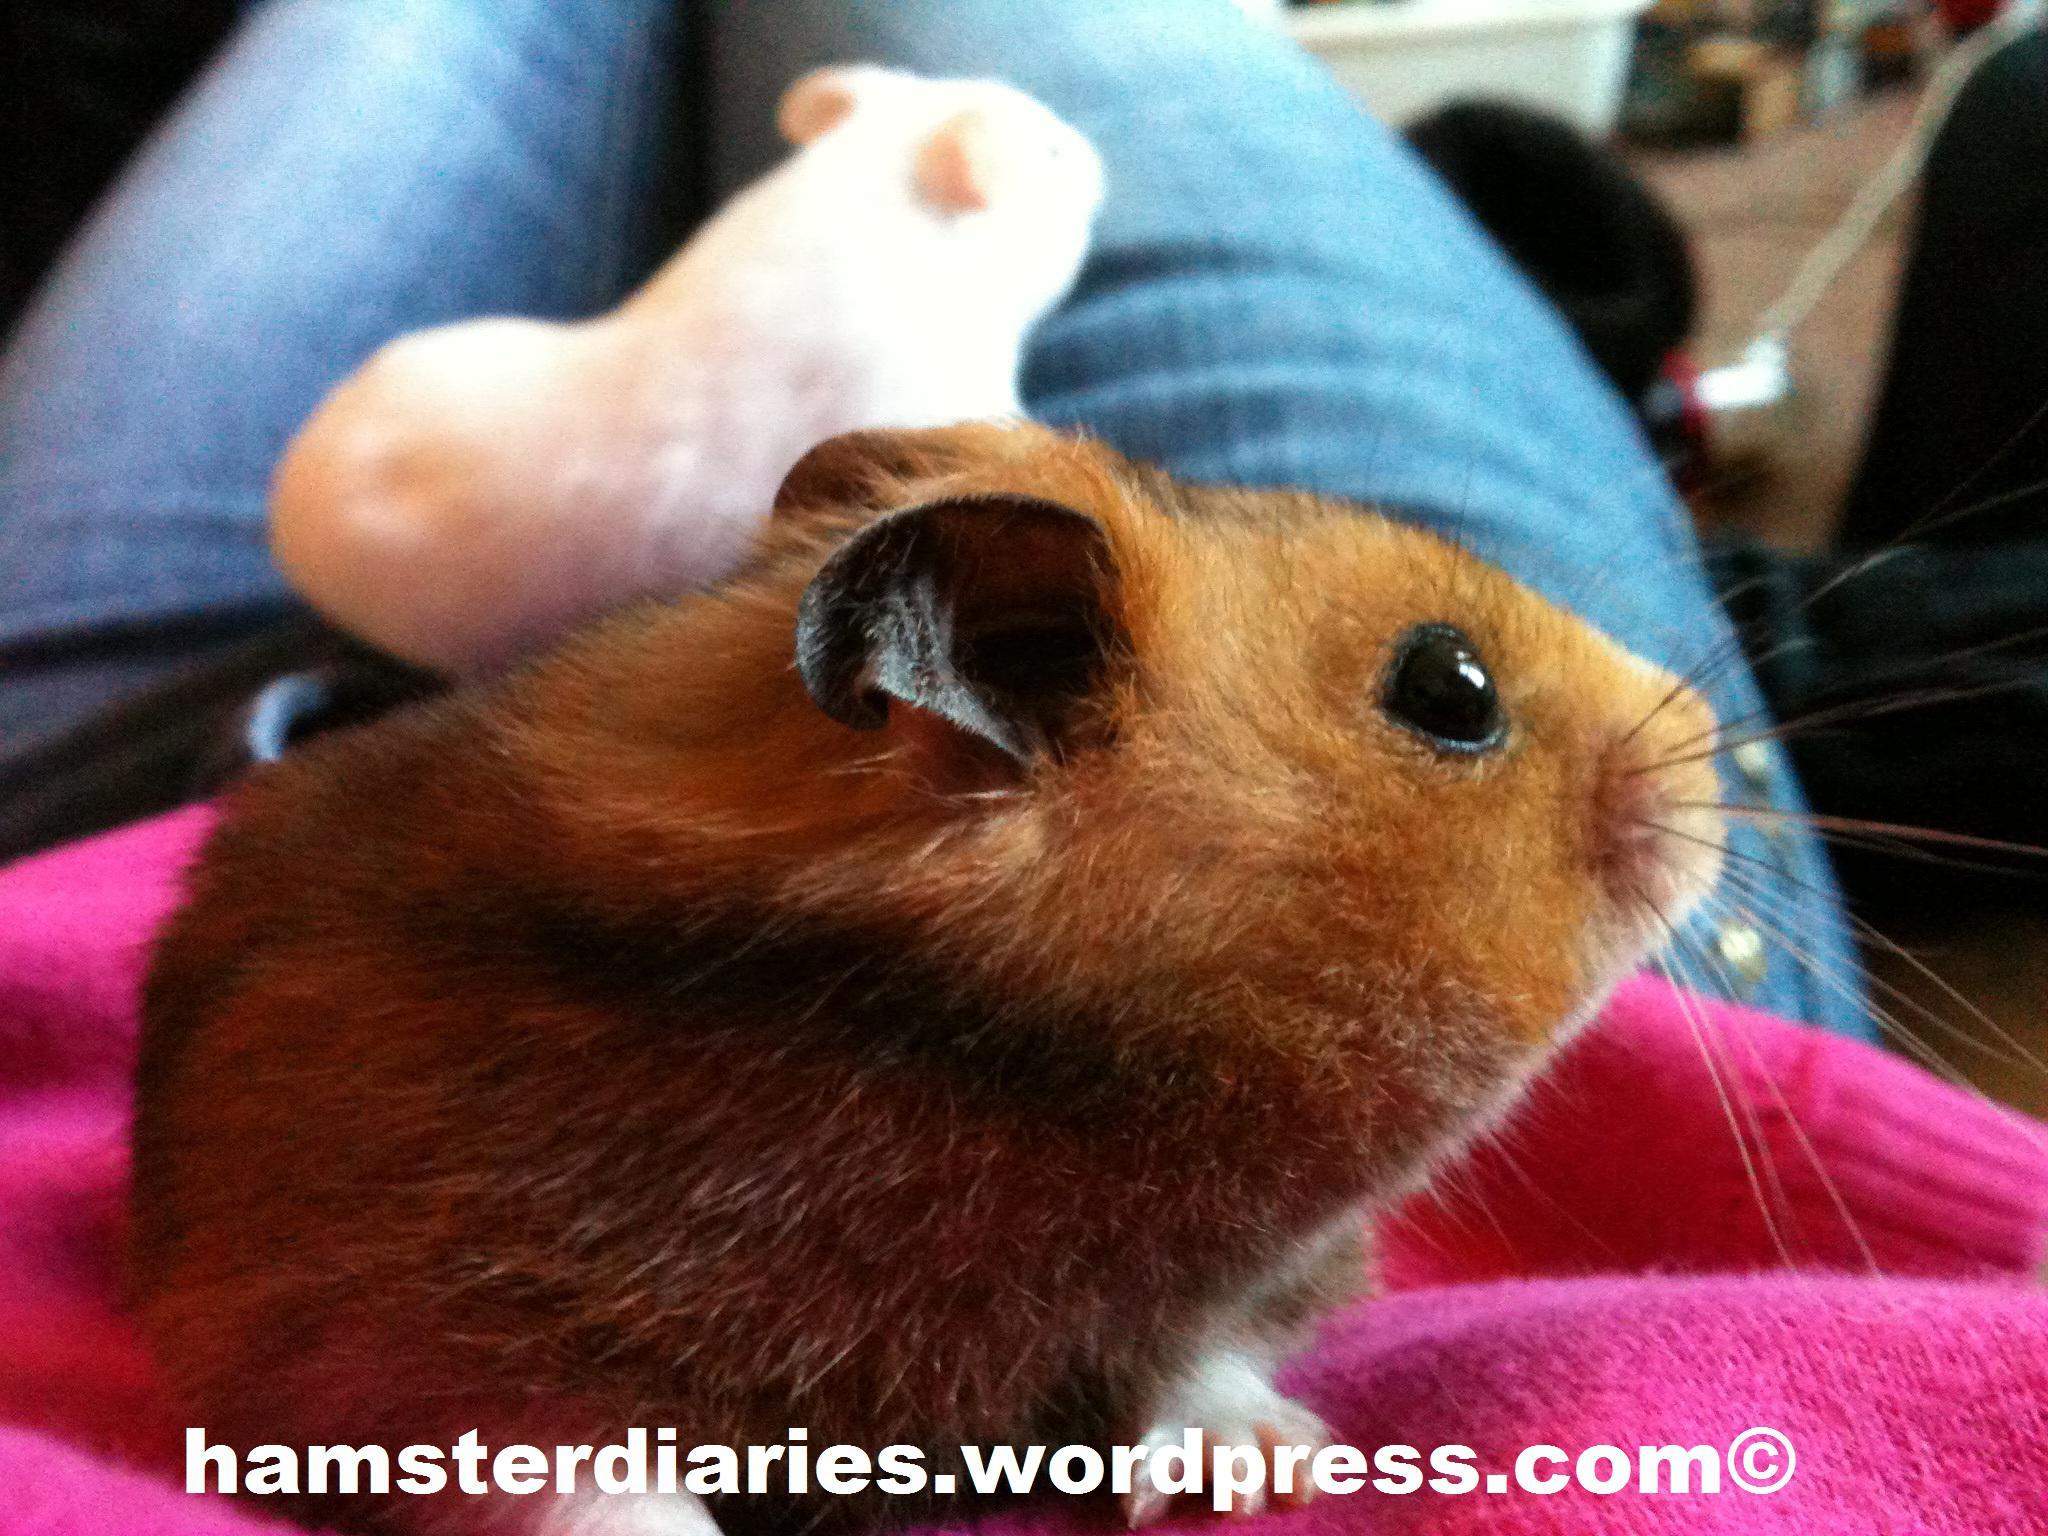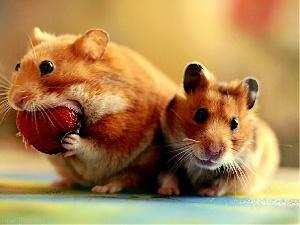The first image is the image on the left, the second image is the image on the right. Assess this claim about the two images: "An image includes an upright hamster grasping a piece of food nearly as big as its head.". Correct or not? Answer yes or no. Yes. The first image is the image on the left, the second image is the image on the right. Examine the images to the left and right. Is the description "A hamster in the right image is eating something." accurate? Answer yes or no. Yes. 